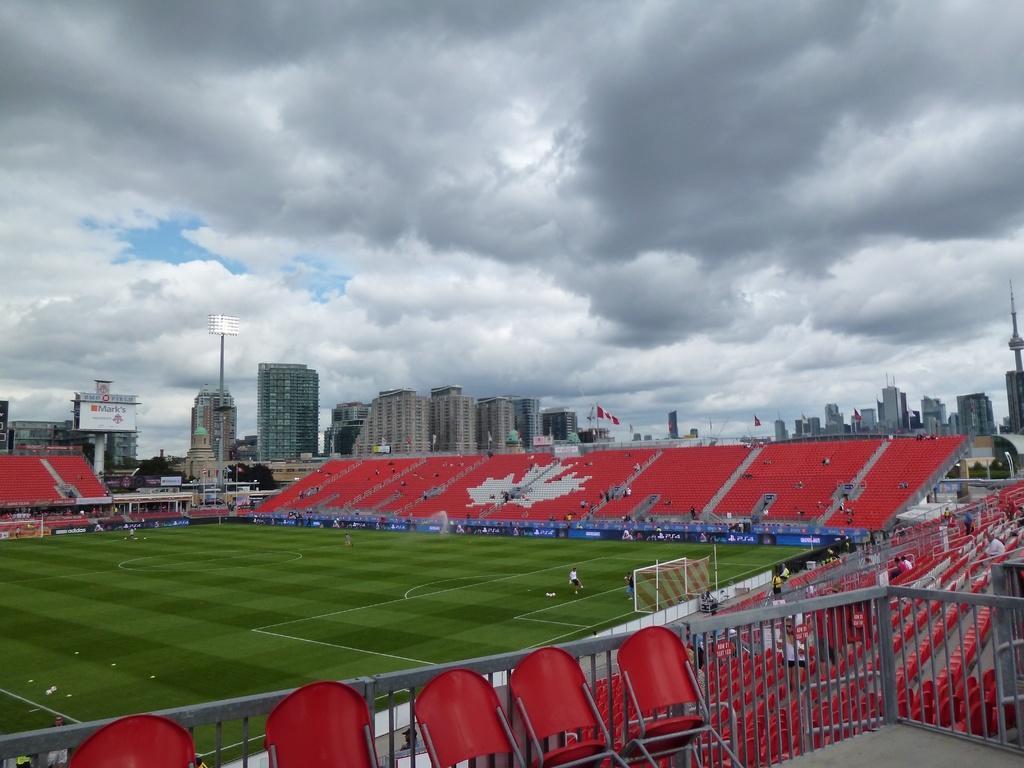Could you give a brief overview of what you see in this image? This is the picture of a stadium. In this image there are group of people sitting in the stadium and there are two persons in the ground. At the back there are buildings and poles and there are lights and hoarding on the pole. At the top there is sky and there are clouds. At the bottom there is grass. In the foreground there are chairs and there is a railing. 